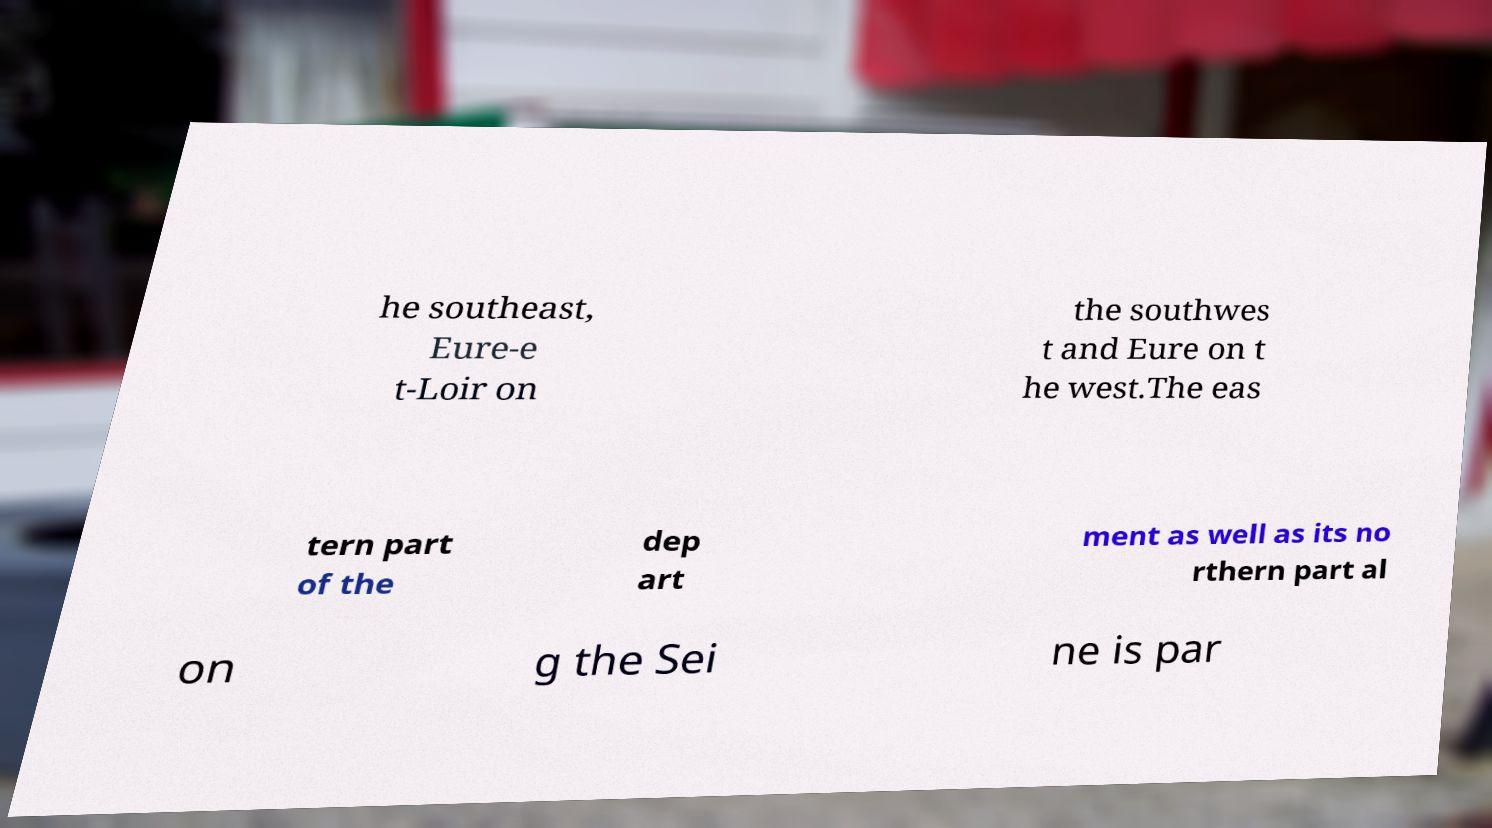Please read and relay the text visible in this image. What does it say? he southeast, Eure-e t-Loir on the southwes t and Eure on t he west.The eas tern part of the dep art ment as well as its no rthern part al on g the Sei ne is par 